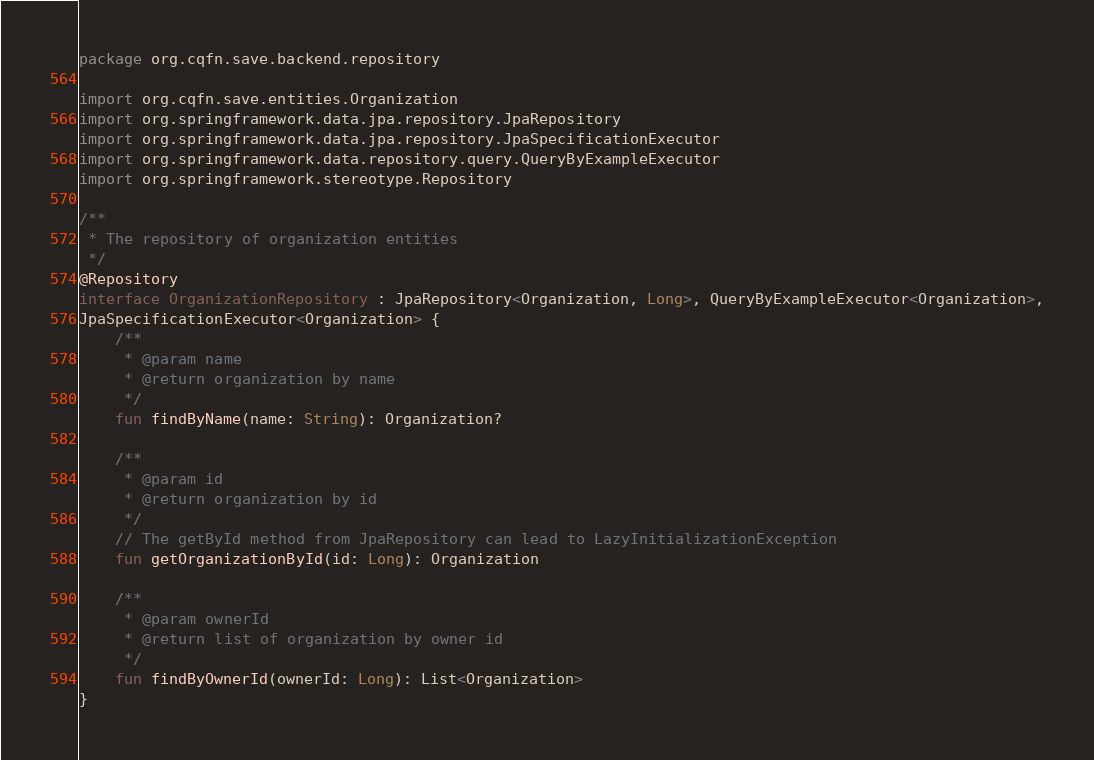Convert code to text. <code><loc_0><loc_0><loc_500><loc_500><_Kotlin_>package org.cqfn.save.backend.repository

import org.cqfn.save.entities.Organization
import org.springframework.data.jpa.repository.JpaRepository
import org.springframework.data.jpa.repository.JpaSpecificationExecutor
import org.springframework.data.repository.query.QueryByExampleExecutor
import org.springframework.stereotype.Repository

/**
 * The repository of organization entities
 */
@Repository
interface OrganizationRepository : JpaRepository<Organization, Long>, QueryByExampleExecutor<Organization>,
JpaSpecificationExecutor<Organization> {
    /**
     * @param name
     * @return organization by name
     */
    fun findByName(name: String): Organization?

    /**
     * @param id
     * @return organization by id
     */
    // The getById method from JpaRepository can lead to LazyInitializationException
    fun getOrganizationById(id: Long): Organization

    /**
     * @param ownerId
     * @return list of organization by owner id
     */
    fun findByOwnerId(ownerId: Long): List<Organization>
}
</code> 